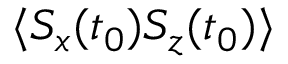Convert formula to latex. <formula><loc_0><loc_0><loc_500><loc_500>\langle S _ { x } ( t _ { 0 } ) S _ { z } ( t _ { 0 } ) \rangle</formula> 